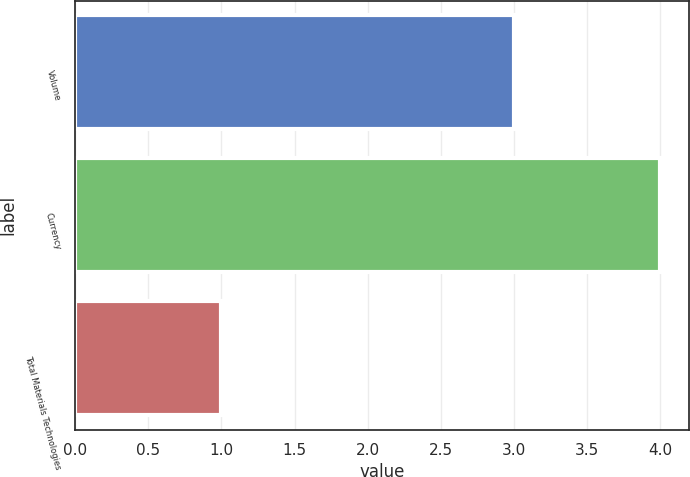<chart> <loc_0><loc_0><loc_500><loc_500><bar_chart><fcel>Volume<fcel>Currency<fcel>Total Materials Technologies<nl><fcel>3<fcel>4<fcel>1<nl></chart> 